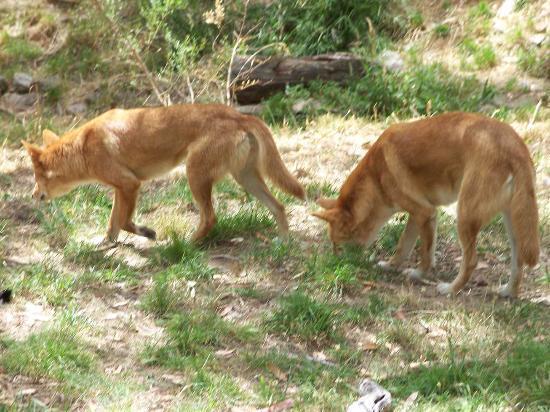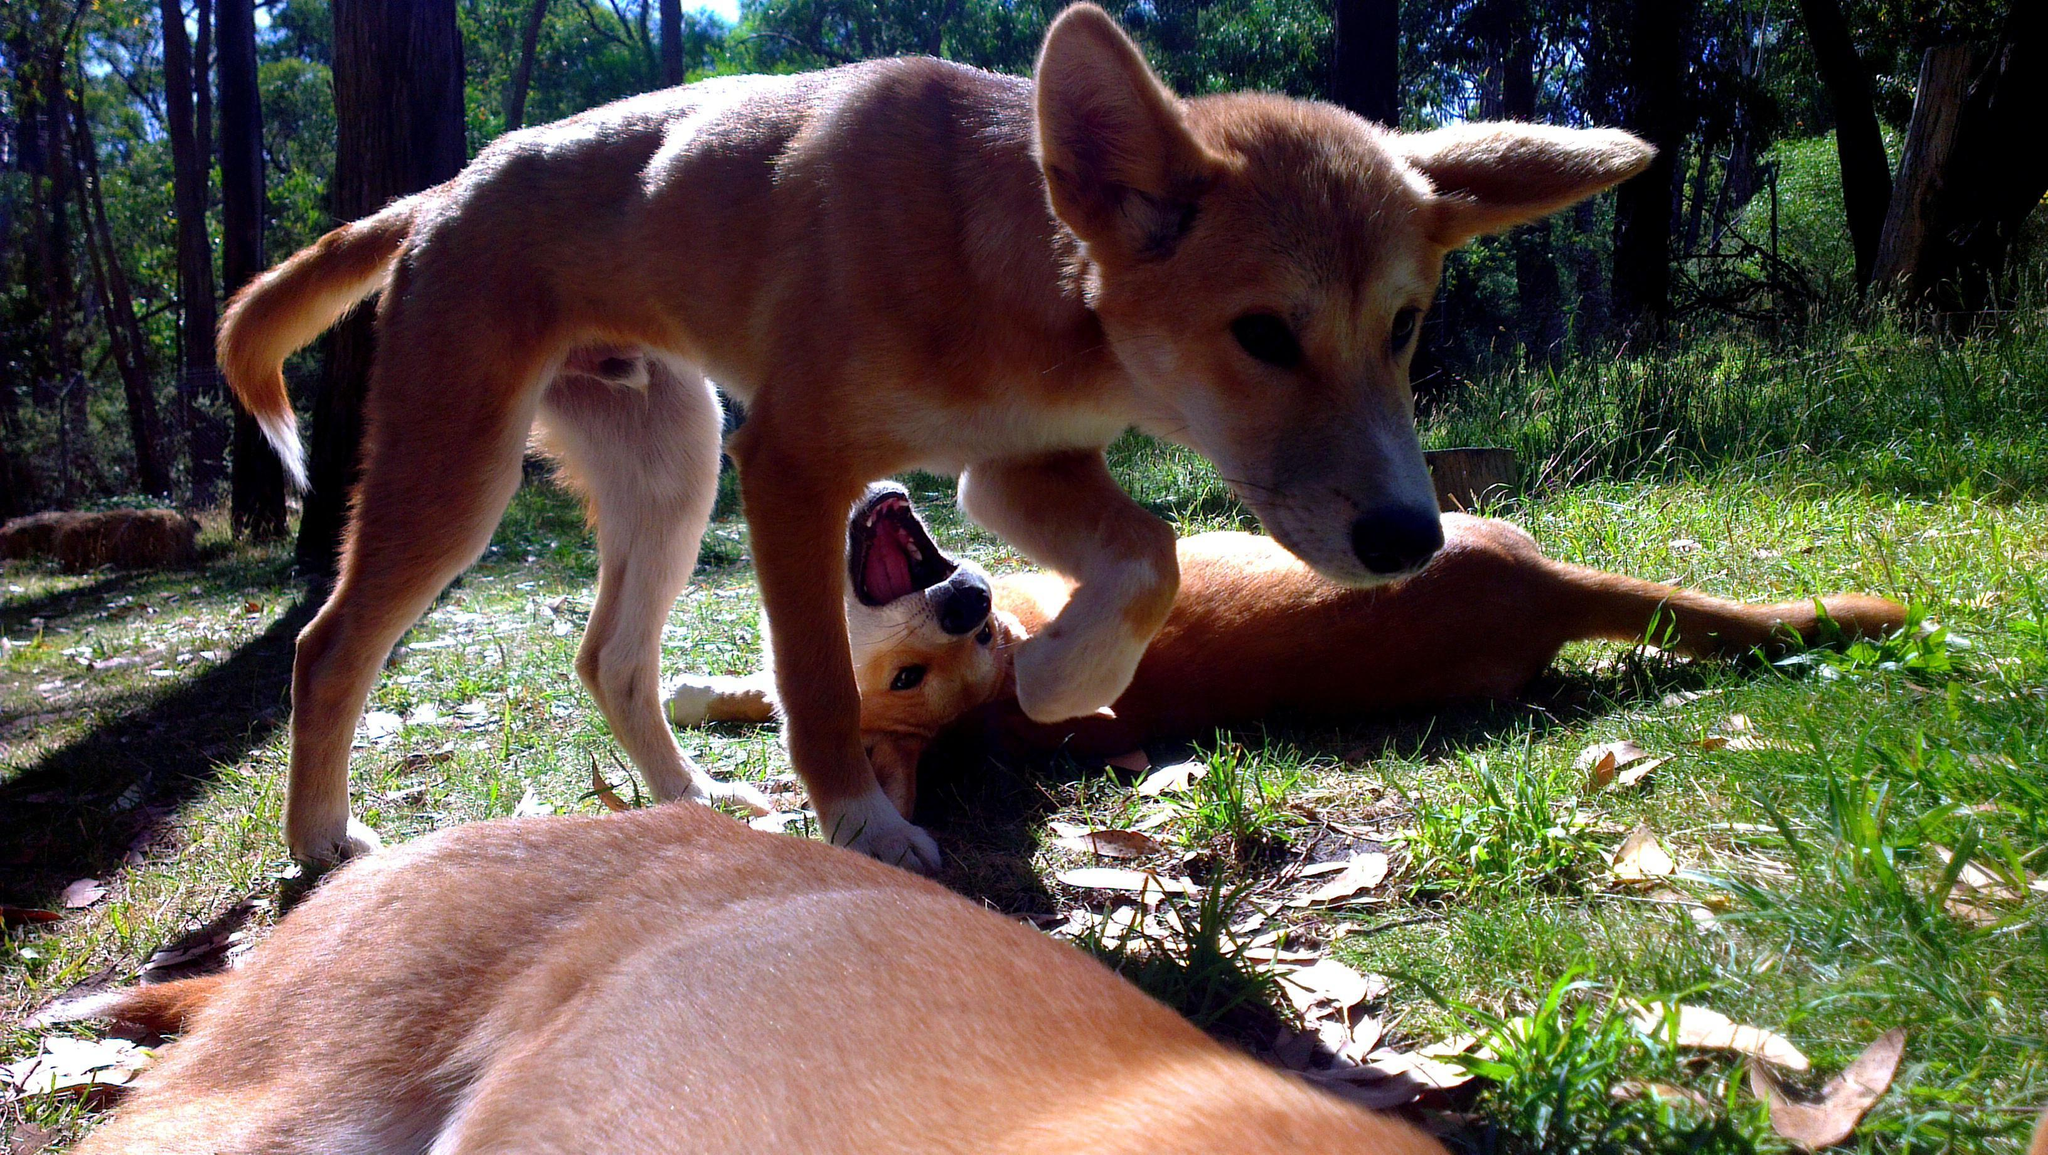The first image is the image on the left, the second image is the image on the right. Evaluate the accuracy of this statement regarding the images: "There are exactly three dogs in total.". Is it true? Answer yes or no. No. The first image is the image on the left, the second image is the image on the right. Assess this claim about the two images: "A single dog is standing on the ground in the woods in the image on the left.". Correct or not? Answer yes or no. No. 